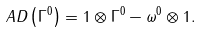<formula> <loc_0><loc_0><loc_500><loc_500>\ A D \left ( \Gamma ^ { 0 } \right ) = 1 \otimes \Gamma ^ { 0 } - \omega ^ { 0 } \otimes 1 .</formula> 